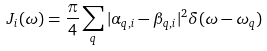<formula> <loc_0><loc_0><loc_500><loc_500>J _ { i } ( \omega ) = \frac { \pi } { 4 } \sum _ { q } | \alpha _ { q , i } - \beta _ { q , i } | ^ { 2 } \delta ( \omega - \omega _ { q } )</formula> 